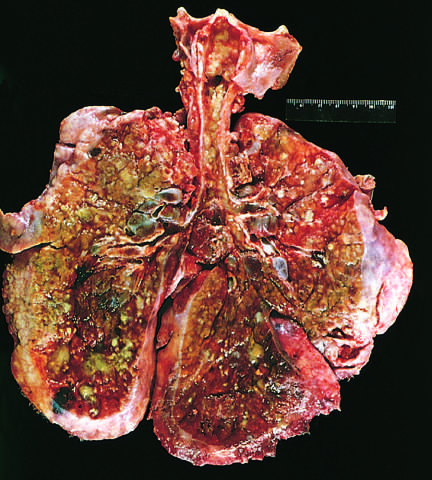what is the product of pseudomonas infections?
Answer the question using a single word or phrase. Greenish discoloration 